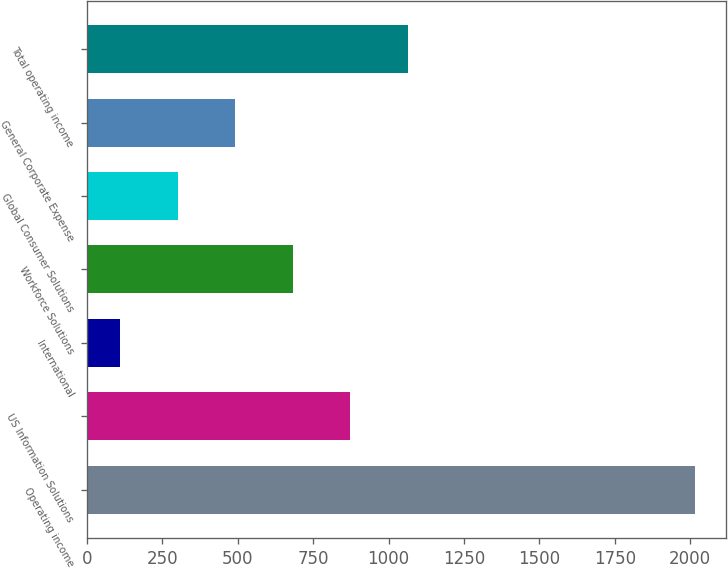Convert chart. <chart><loc_0><loc_0><loc_500><loc_500><bar_chart><fcel>Operating income<fcel>US Information Solutions<fcel>International<fcel>Workforce Solutions<fcel>Global Consumer Solutions<fcel>General Corporate Expense<fcel>Total operating income<nl><fcel>2016<fcel>873.24<fcel>111.4<fcel>682.78<fcel>301.86<fcel>492.32<fcel>1063.7<nl></chart> 